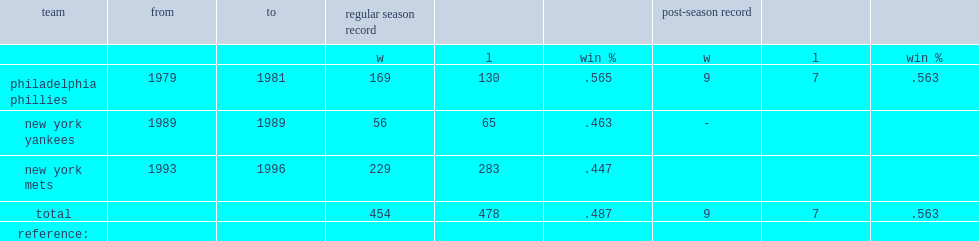What was the w-l record in the regular season of phillies? 169.0 130.0. 